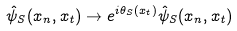<formula> <loc_0><loc_0><loc_500><loc_500>\hat { \psi } _ { S } ( x _ { n } , x _ { t } ) \to e ^ { i \theta _ { S } ( x _ { t } ) } \hat { \psi } _ { S } ( x _ { n } , x _ { t } )</formula> 